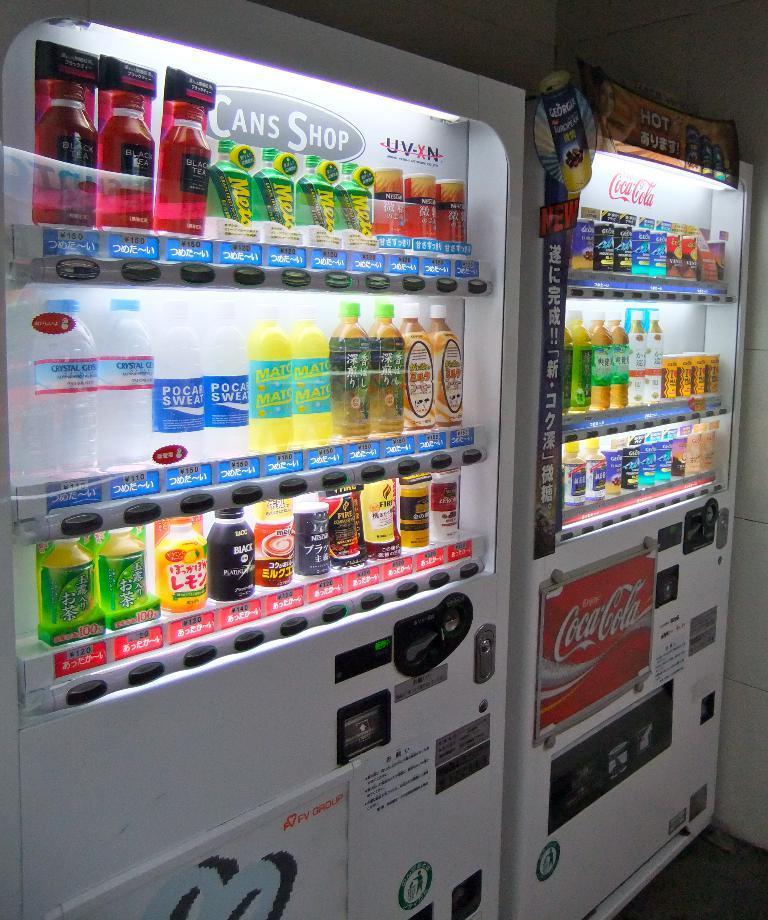Could you give a brief overview of what you see in this image? In this image there are refrigerators and we can see beverages placed in the refrigerators. In the background there is a wall. 